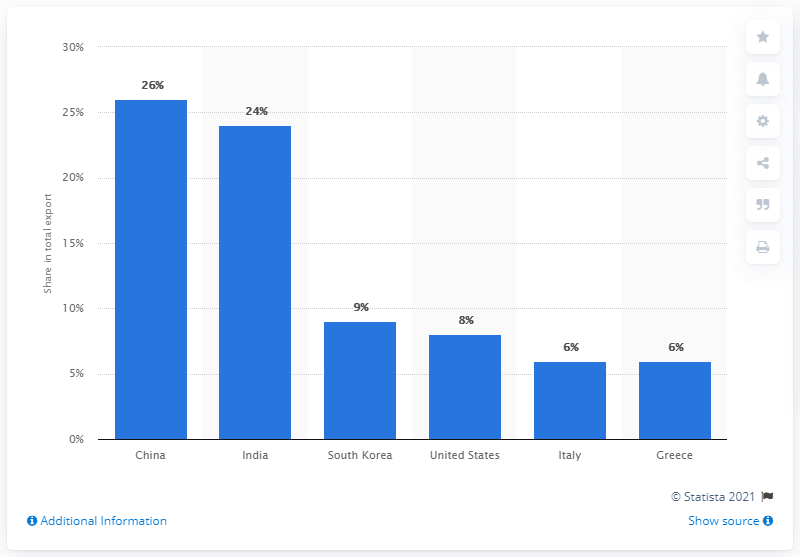Draw attention to some important aspects in this diagram. In 2019, China was Iraq's most important export partner, accounting for the majority of the country's total exports. 